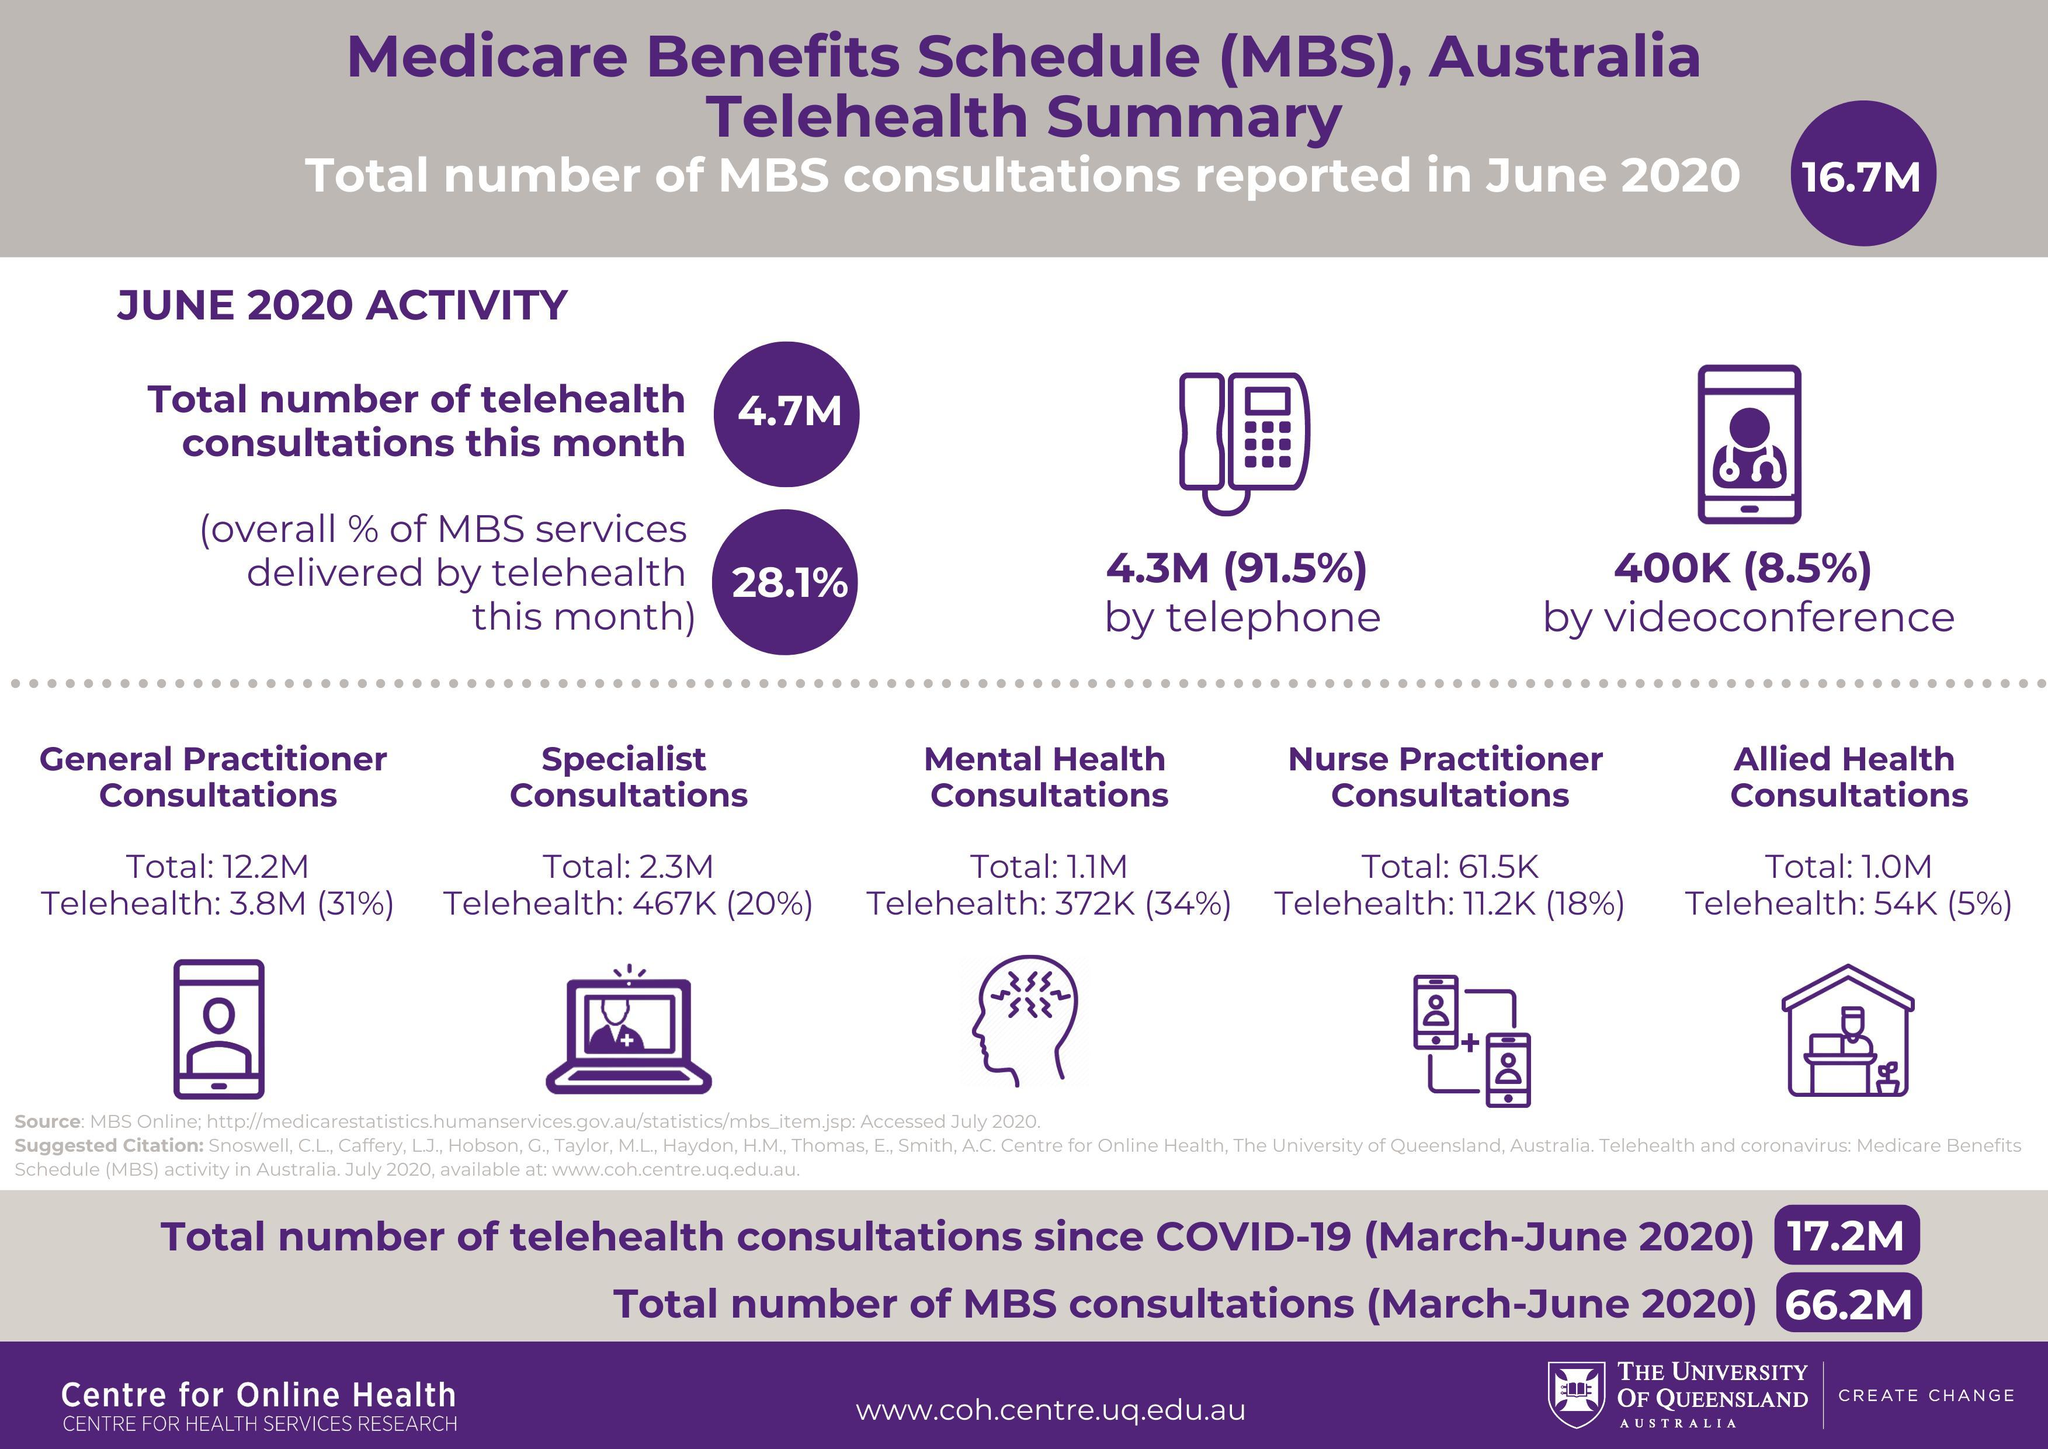WHat % of consultations were conducted on phone in June 2020
Answer the question with a short phrase. 91.5% What is the total MBS consultation in million from March to May 2020 49.5 What is the total telehealth consultation in millions from March to May 2020 12.5 What is the total number of consultation in million via phone or videoconference in June 2020 4.7 What is the total count in Million of specialist consultations and mental health consultations 3.4 WHat % of consultations were conducted by videoconference in June 2020 8.5% 